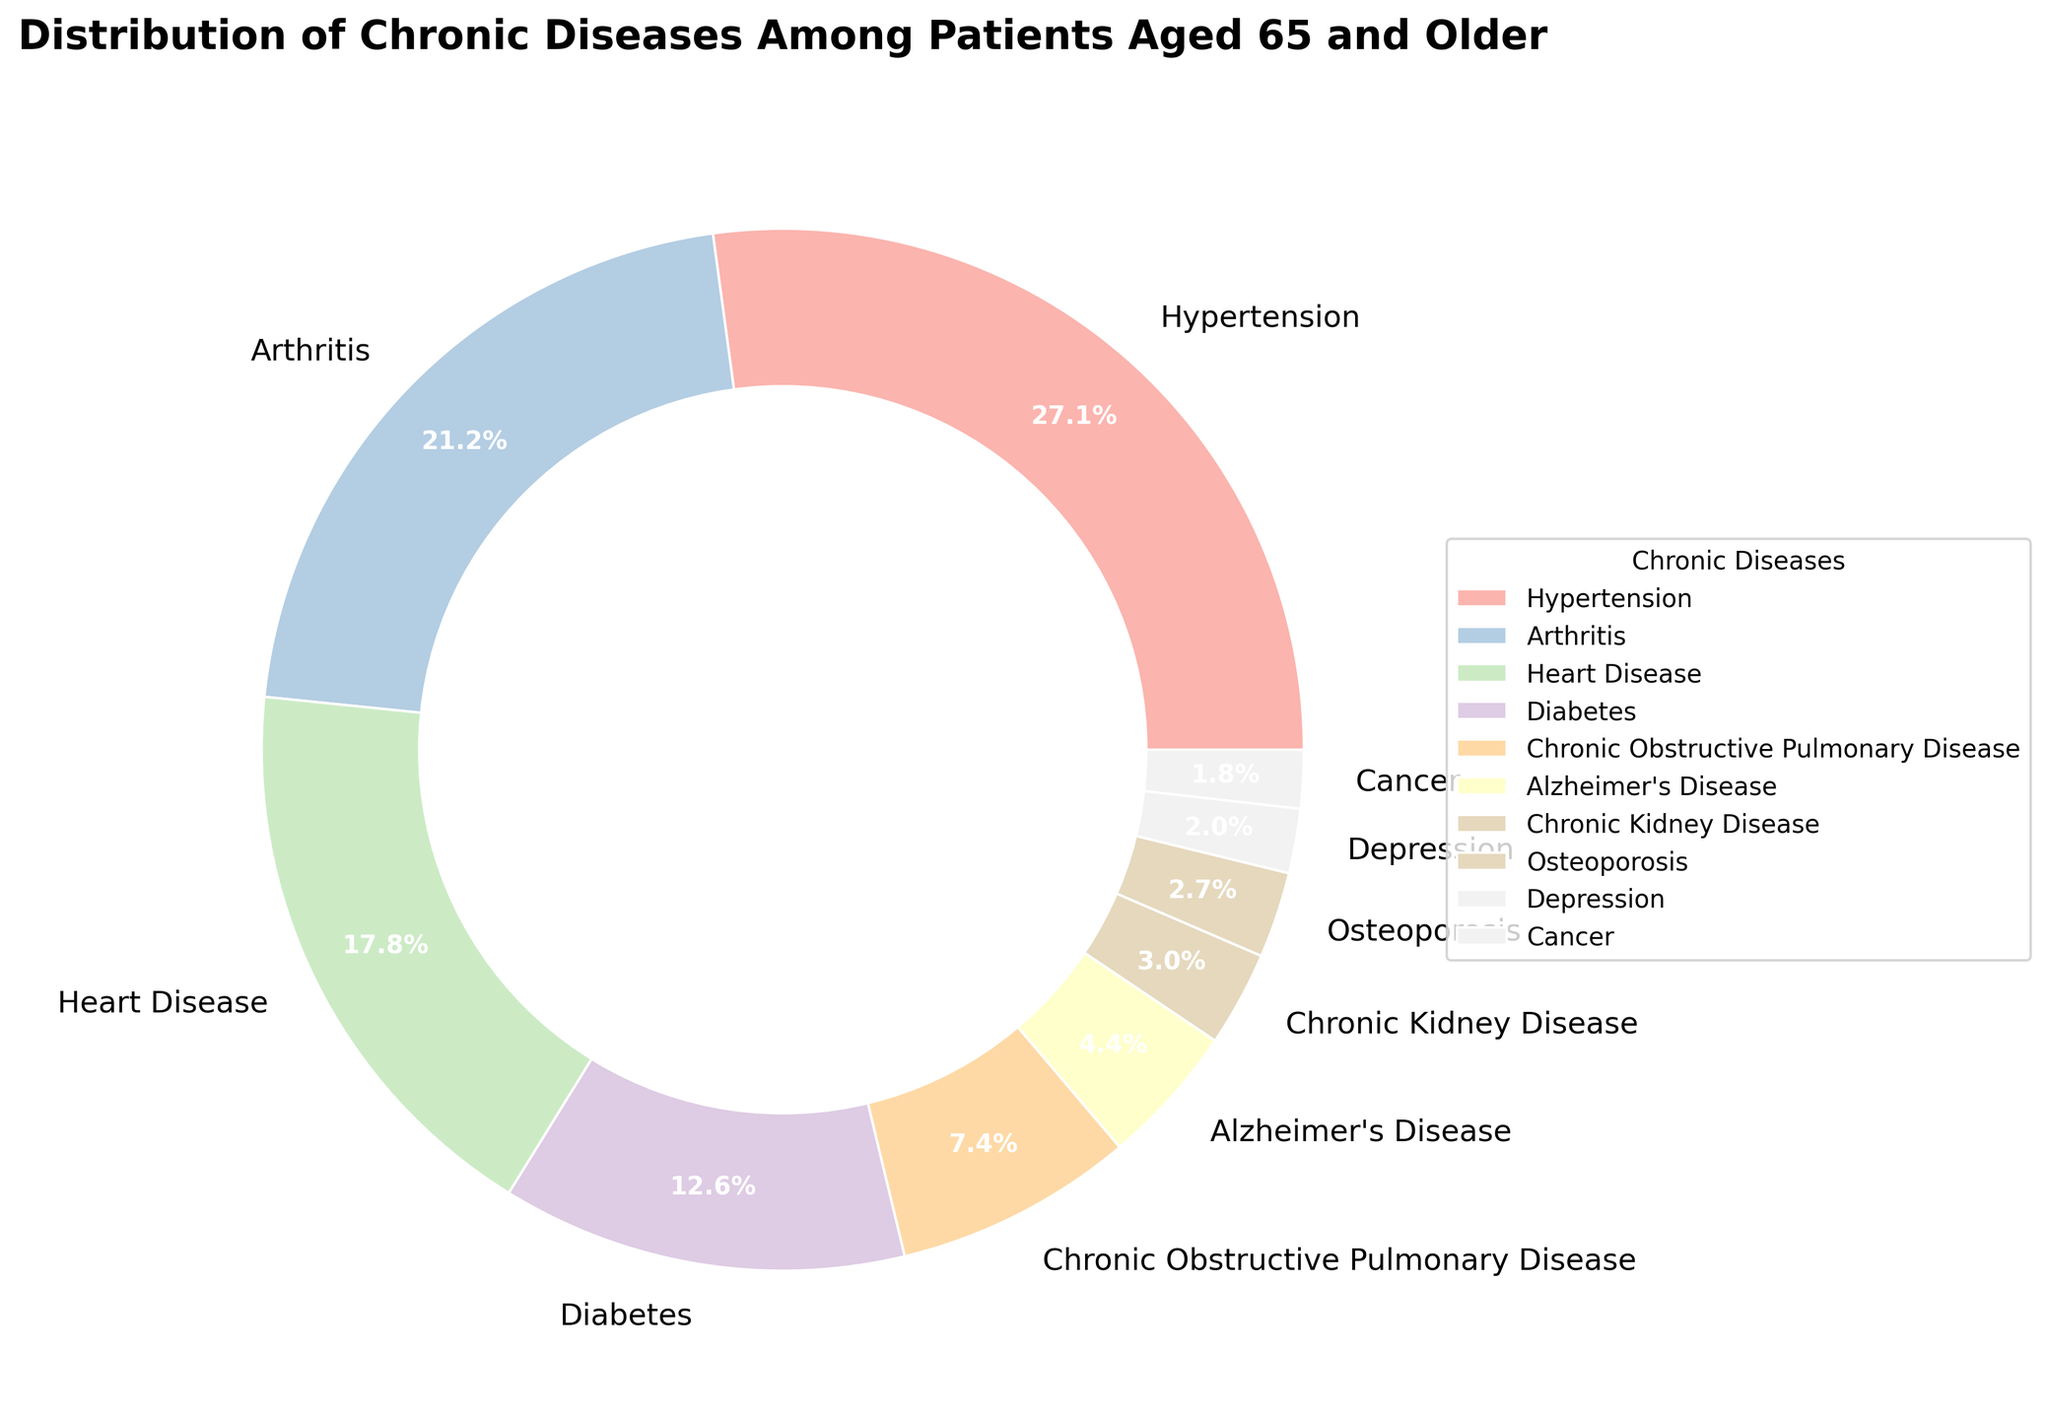What percentage of patients aged 65 and older suffer from arthritis? The pie chart shows different chronic diseases along with their percentages. Look for "Arthritis" in the chart and note the percentage.
Answer: 22.3% Which chronic disease has the highest prevalence among patients aged 65 and older? Identify the section with the largest percentage in the pie chart. The disease with the highest percentage is the most prevalent.
Answer: Hypertension What is the combined percentage of patients suffering from heart disease and diabetes? Find the percentages for "Heart Disease" and "Diabetes" in the chart. Add these percentages together: 18.7% (Heart Disease) + 13.2% (Diabetes) = 31.9%.
Answer: 31.9% Which disease has a higher percentage, Alzheimer's or Chronic Kidney Disease? Compare the percentages for "Alzheimer's Disease" and "Chronic Kidney Disease" shown in the pie chart.
Answer: Alzheimer's Disease What percentage of patients have either COPD or osteoporosis? Find the percentages for "Chronic Obstructive Pulmonary Disease (COPD)" and "Osteoporosis." Add these percentages together: 7.8% (COPD) + 2.8% (Osteoporosis) = 10.6%.
Answer: 10.6% What is the difference in prevalence between arthritis and depression? Note the percentages for "Arthritis" and "Depression" from the pie chart. Subtract the smaller percentage (Depression) from the larger percentage (Arthritis): 22.3% - 2.1% = 20.2%.
Answer: 20.2% How does the percentage of patients with chronic kidney disease compare to the percentage of patients with cancer? Look at the percentages for "Chronic Kidney Disease" and "Cancer" in the chart. Compare them.
Answer: Chronic Kidney Disease What percentage of chronic diseases have a prevalence rate of less than 5%? Identify which diseases have percentages below 5% (Alzheimer's Disease, Chronic Kidney Disease, Osteoporosis, Depression, Cancer) and count them.
Answer: 5 diseases What is the total percentage of patients suffering from hypertension, arthritis, and heart disease? Add the percentages of the top three chronic diseases: 28.5% (Hypertension) + 22.3% (Arthritis) + 18.7% (Heart Disease) = 69.5%.
Answer: 69.5% 